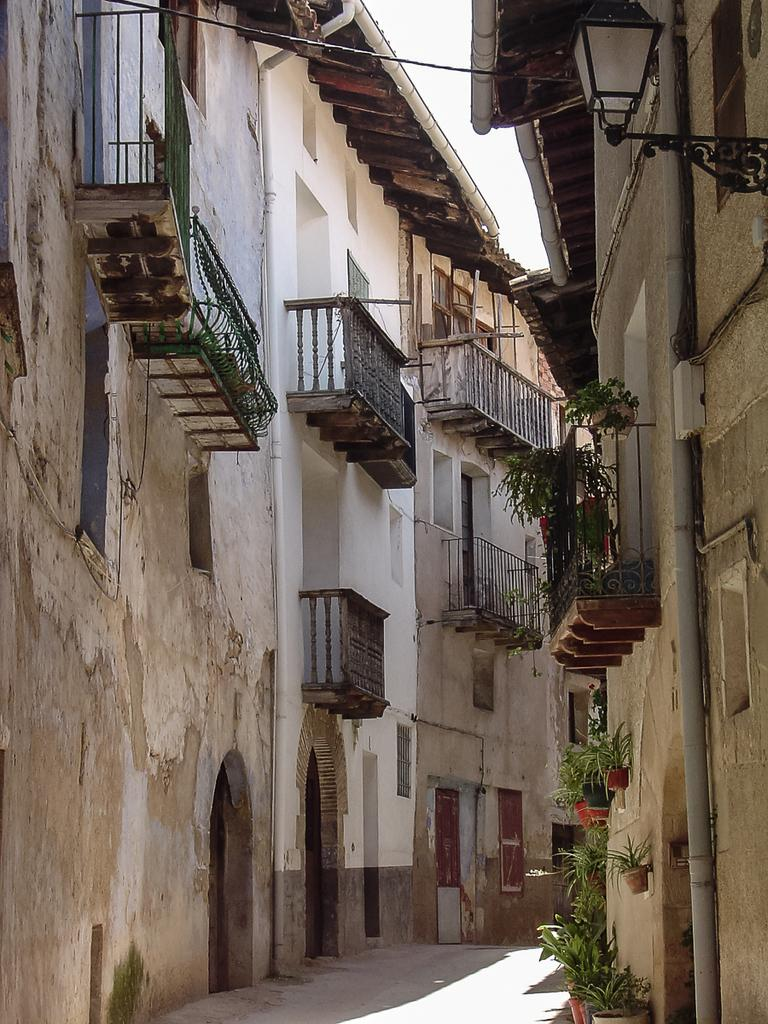What type of pathway is present in the image? There is a road in the image. What type of structures can be seen in the image? There are buildings in the image. What type of vegetation is present in the image? There are house plants in the image. What type of illumination is visible in the image? There is light visible in the image. What type of objects are present in the image? There are objects in the image. What type of natural scenery is visible in the background of the image? The sky is visible in the background of the image. What type of yoke is visible in the image? There is no yoke present in the image. Is there a bridge visible in the image? No, there is no bridge visible in the image. 